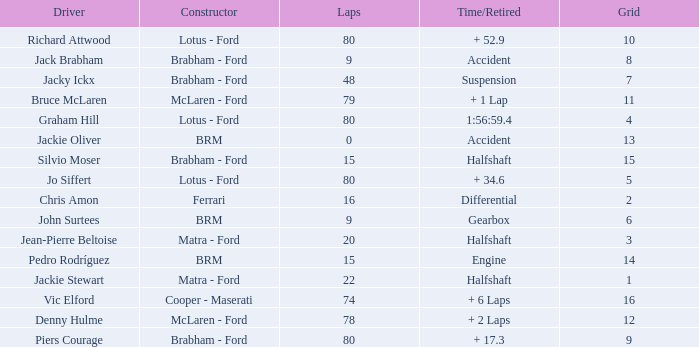What is the time/retired for brm with a grid of 13? Accident. 